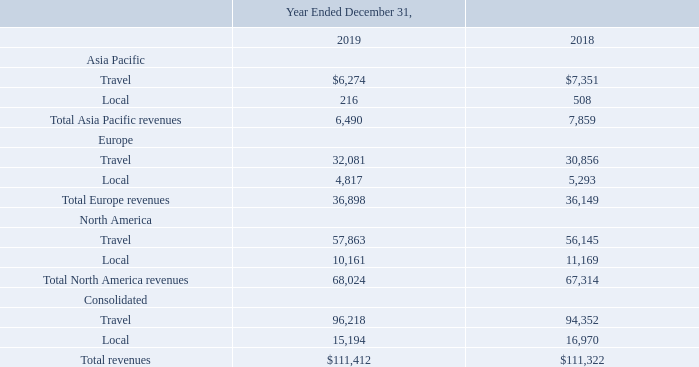Revenues
The following table sets forth the breakdown of revenues (in thousands) by category and segment. Travel revenue includes travel publications (Top 20, Website, Newsflash, Travelzoo Network), Getaways vouchers, and hotel platform and vacation packages. Local revenue includes Local Deals vouchers and entertainment offers (vouchers and direct bookings).
Asia Pacific
Asia Pacific revenues decreased $1.4 million or 17% in 2019 compared to 2018. This decrease was primarily due to the decrease in Travel revenues, the decrease in Local revenues and a $206,000 negative impact from foreign currency movements relative to the U.S. dollar. The decrease in Travel revenues of $887,000 was primarily due to a decrease of number of emails sent. The decrease in Local revenues of $276,000 was primarily due to the decreased number of Local Deals vouchers sold.
Europe
Europe revenues increased $749,000 or 2% in 2019 compared to 2018. This increase was primarily due to the increase in Travel revenues, the decrease in Local revenues and a $1.8 million negative impact from foreign currency movements relative to the U.S. dollar. The increase in Travel revenue of $2.9 million was primarily due to the increased number of emails sent. The decrease in Local revenues of $292,000 was primarily due to the decreased number of Local Deals vouchers sold.
North America
North America revenues increased $710,000 or 1% in 2019 compared to 2018. This increase was primarily due to the increase in Travel revenues offset by the decrease in Local revenue. The increase in Travel revenue of $1.7 million was primarily due to the increased number of emails sent. The decrease in Local revenues of $1.0 was primarily due to the decreased number of Local Deals vouchers sold.
For 2019 and 2018 , none of our customers accounted for 10% or more of our revenue.
What is the total revenues from Asia Pacific in 2019 and 2018 respectively?
Answer scale should be: thousand. 6,490, 7,859. What is the total revenues from Europe in 2019 and 2018 respectively?
Answer scale should be: thousand. 36,898, 36,149. What is the total revenues from North America in 2019 and 2018 respectively?
Answer scale should be: thousand. 68,024, 67,314. In 2019, how many geographic regions have total revenues of more than $5,000 thousand? Asia Pacific ## Europe ## North America
Answer: 3. What is the change in the total North America revenue between 2018 and 2019?
Answer scale should be: thousand. 68,024-67,314
Answer: 710. In 2018, which geographic region has the highest total revenue? Look at the total revenues from the respective geographic regions in 2018 and compare
Answer: north america. 